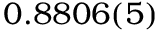<formula> <loc_0><loc_0><loc_500><loc_500>0 . 8 8 0 6 ( 5 )</formula> 